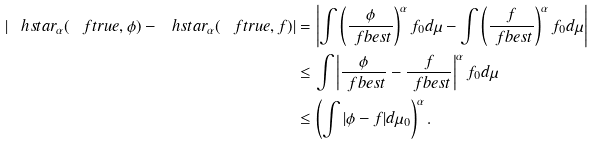<formula> <loc_0><loc_0><loc_500><loc_500>| \ h s t a r _ { \alpha } ( \ f t r u e , \phi ) - \ h s t a r _ { \alpha } ( \ f t r u e , f ) | & = \left | \int \left ( \frac { \phi } { \ f b e s t } \right ) ^ { \alpha } f _ { 0 } d \mu - \int \left ( \frac { f } { \ f b e s t } \right ) ^ { \alpha } f _ { 0 } d \mu \right | \\ & \leq \int \left | \frac { \phi } { \ f b e s t } - \frac { f } { \ f b e s t } \right | ^ { \alpha } f _ { 0 } d \mu \\ & \leq \left ( \int | \phi - f | d \mu _ { 0 } \right ) ^ { \alpha } .</formula> 